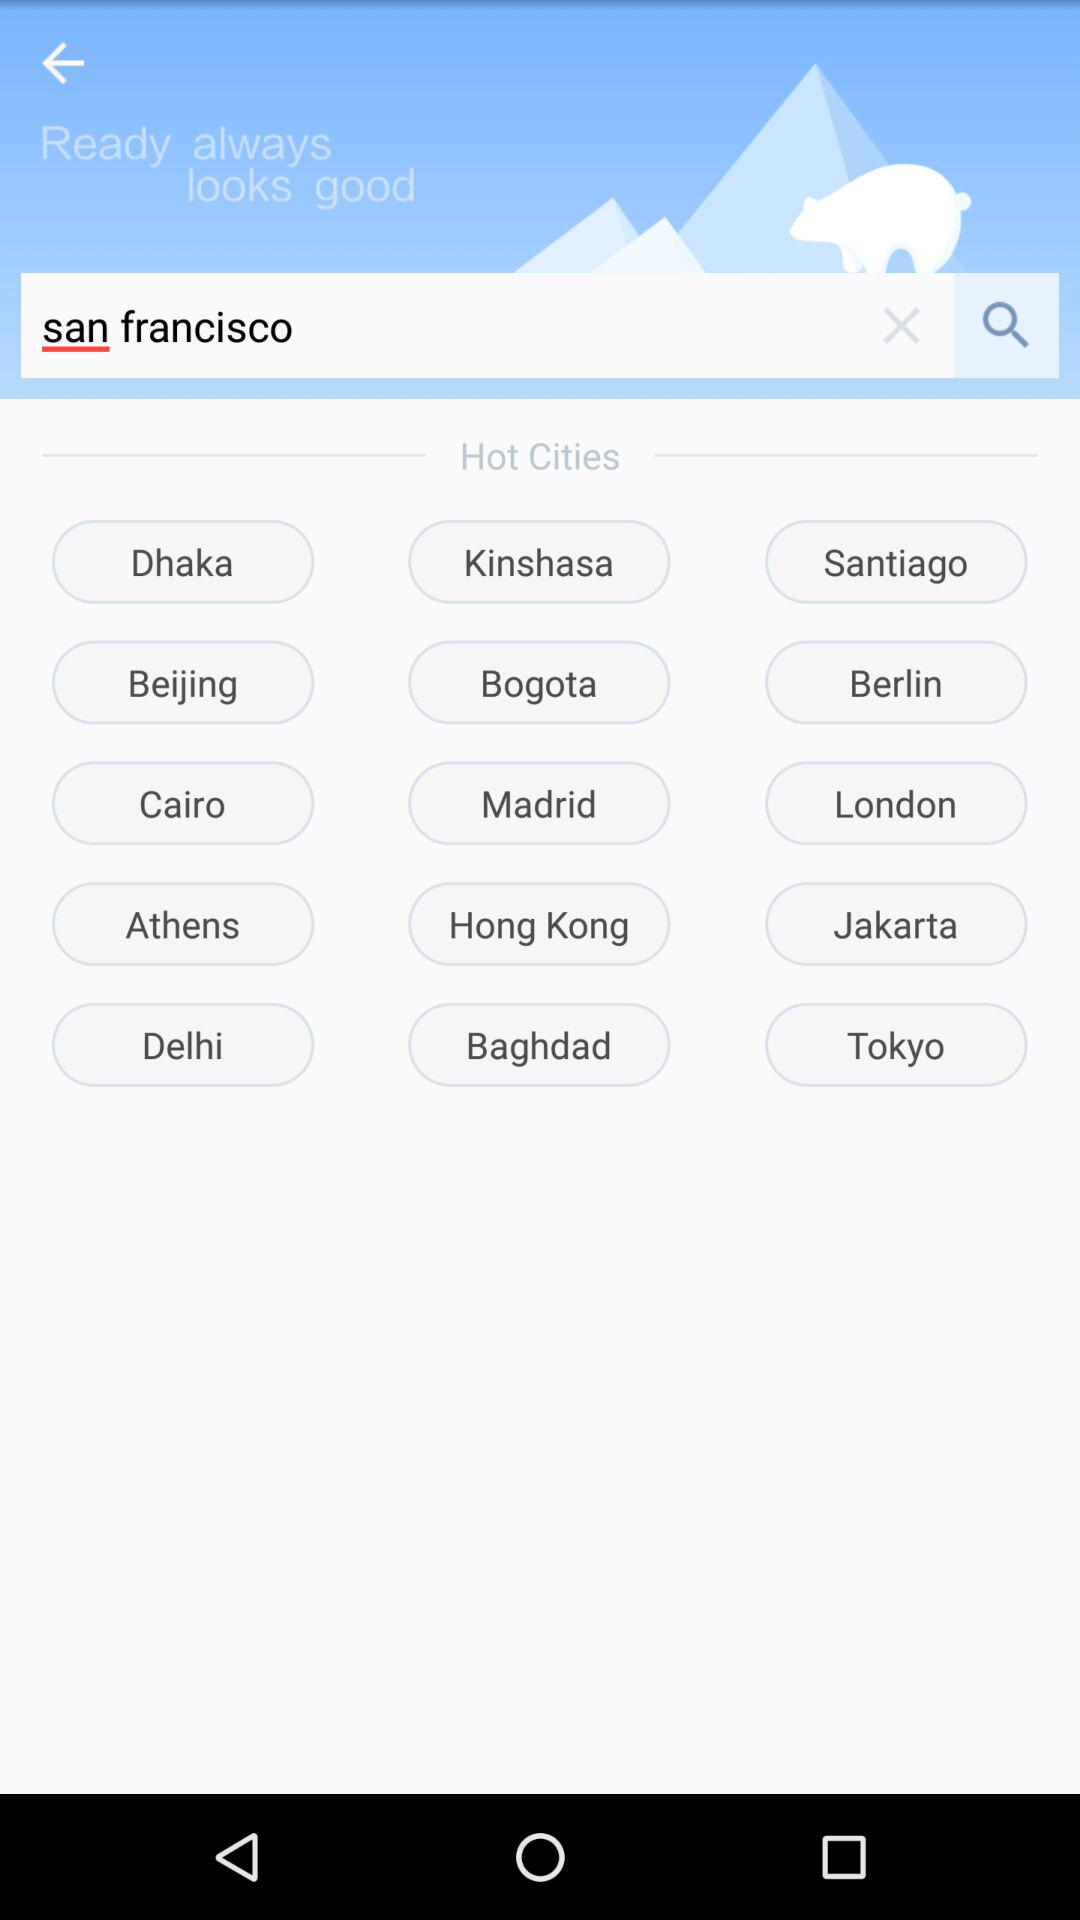What location is entered in the search bar? The location entered in the search bar is San Francisco. 